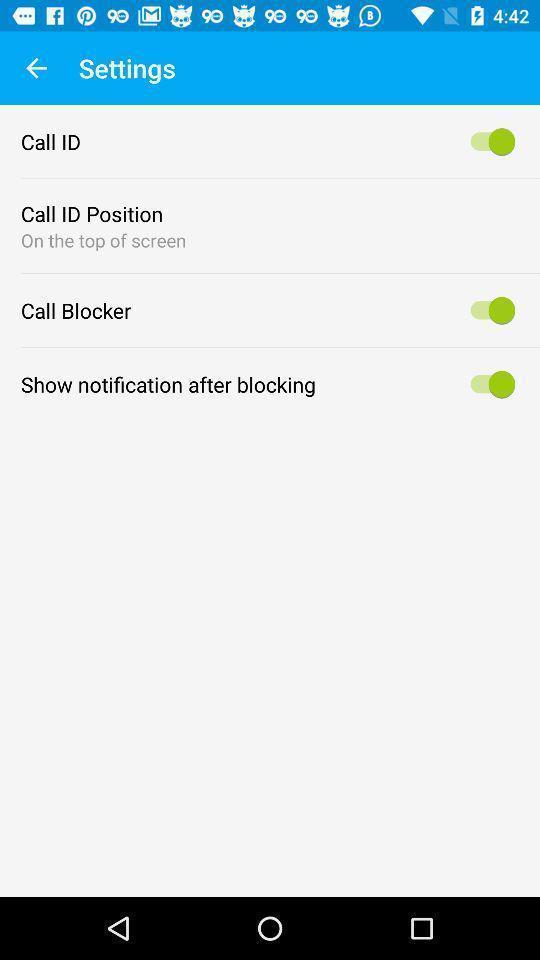Explain what's happening in this screen capture. Settings regarding calls in the application. 